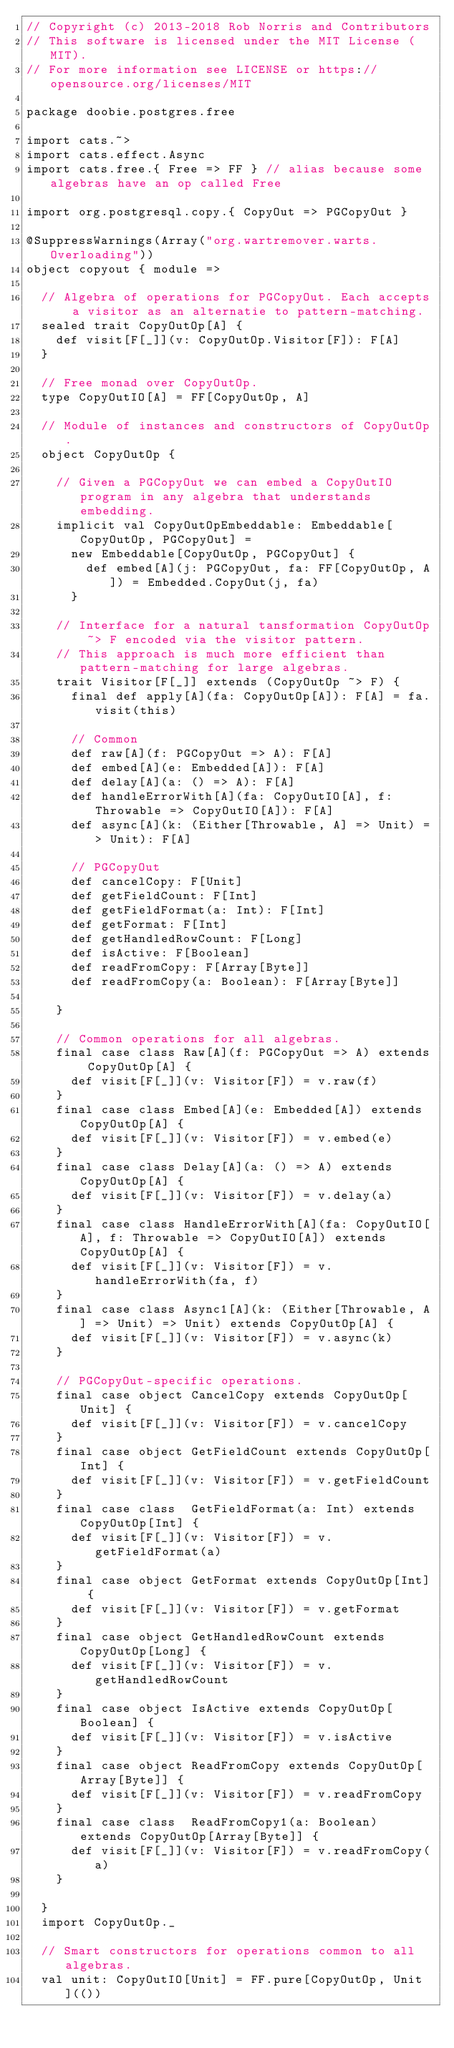<code> <loc_0><loc_0><loc_500><loc_500><_Scala_>// Copyright (c) 2013-2018 Rob Norris and Contributors
// This software is licensed under the MIT License (MIT).
// For more information see LICENSE or https://opensource.org/licenses/MIT

package doobie.postgres.free

import cats.~>
import cats.effect.Async
import cats.free.{ Free => FF } // alias because some algebras have an op called Free

import org.postgresql.copy.{ CopyOut => PGCopyOut }

@SuppressWarnings(Array("org.wartremover.warts.Overloading"))
object copyout { module =>

  // Algebra of operations for PGCopyOut. Each accepts a visitor as an alternatie to pattern-matching.
  sealed trait CopyOutOp[A] {
    def visit[F[_]](v: CopyOutOp.Visitor[F]): F[A]
  }

  // Free monad over CopyOutOp.
  type CopyOutIO[A] = FF[CopyOutOp, A]

  // Module of instances and constructors of CopyOutOp.
  object CopyOutOp {

    // Given a PGCopyOut we can embed a CopyOutIO program in any algebra that understands embedding.
    implicit val CopyOutOpEmbeddable: Embeddable[CopyOutOp, PGCopyOut] =
      new Embeddable[CopyOutOp, PGCopyOut] {
        def embed[A](j: PGCopyOut, fa: FF[CopyOutOp, A]) = Embedded.CopyOut(j, fa)
      }

    // Interface for a natural tansformation CopyOutOp ~> F encoded via the visitor pattern.
    // This approach is much more efficient than pattern-matching for large algebras.
    trait Visitor[F[_]] extends (CopyOutOp ~> F) {
      final def apply[A](fa: CopyOutOp[A]): F[A] = fa.visit(this)

      // Common
      def raw[A](f: PGCopyOut => A): F[A]
      def embed[A](e: Embedded[A]): F[A]
      def delay[A](a: () => A): F[A]
      def handleErrorWith[A](fa: CopyOutIO[A], f: Throwable => CopyOutIO[A]): F[A]
      def async[A](k: (Either[Throwable, A] => Unit) => Unit): F[A]

      // PGCopyOut
      def cancelCopy: F[Unit]
      def getFieldCount: F[Int]
      def getFieldFormat(a: Int): F[Int]
      def getFormat: F[Int]
      def getHandledRowCount: F[Long]
      def isActive: F[Boolean]
      def readFromCopy: F[Array[Byte]]
      def readFromCopy(a: Boolean): F[Array[Byte]]

    }

    // Common operations for all algebras.
    final case class Raw[A](f: PGCopyOut => A) extends CopyOutOp[A] {
      def visit[F[_]](v: Visitor[F]) = v.raw(f)
    }
    final case class Embed[A](e: Embedded[A]) extends CopyOutOp[A] {
      def visit[F[_]](v: Visitor[F]) = v.embed(e)
    }
    final case class Delay[A](a: () => A) extends CopyOutOp[A] {
      def visit[F[_]](v: Visitor[F]) = v.delay(a)
    }
    final case class HandleErrorWith[A](fa: CopyOutIO[A], f: Throwable => CopyOutIO[A]) extends CopyOutOp[A] {
      def visit[F[_]](v: Visitor[F]) = v.handleErrorWith(fa, f)
    }
    final case class Async1[A](k: (Either[Throwable, A] => Unit) => Unit) extends CopyOutOp[A] {
      def visit[F[_]](v: Visitor[F]) = v.async(k)
    }

    // PGCopyOut-specific operations.
    final case object CancelCopy extends CopyOutOp[Unit] {
      def visit[F[_]](v: Visitor[F]) = v.cancelCopy
    }
    final case object GetFieldCount extends CopyOutOp[Int] {
      def visit[F[_]](v: Visitor[F]) = v.getFieldCount
    }
    final case class  GetFieldFormat(a: Int) extends CopyOutOp[Int] {
      def visit[F[_]](v: Visitor[F]) = v.getFieldFormat(a)
    }
    final case object GetFormat extends CopyOutOp[Int] {
      def visit[F[_]](v: Visitor[F]) = v.getFormat
    }
    final case object GetHandledRowCount extends CopyOutOp[Long] {
      def visit[F[_]](v: Visitor[F]) = v.getHandledRowCount
    }
    final case object IsActive extends CopyOutOp[Boolean] {
      def visit[F[_]](v: Visitor[F]) = v.isActive
    }
    final case object ReadFromCopy extends CopyOutOp[Array[Byte]] {
      def visit[F[_]](v: Visitor[F]) = v.readFromCopy
    }
    final case class  ReadFromCopy1(a: Boolean) extends CopyOutOp[Array[Byte]] {
      def visit[F[_]](v: Visitor[F]) = v.readFromCopy(a)
    }

  }
  import CopyOutOp._

  // Smart constructors for operations common to all algebras.
  val unit: CopyOutIO[Unit] = FF.pure[CopyOutOp, Unit](())</code> 